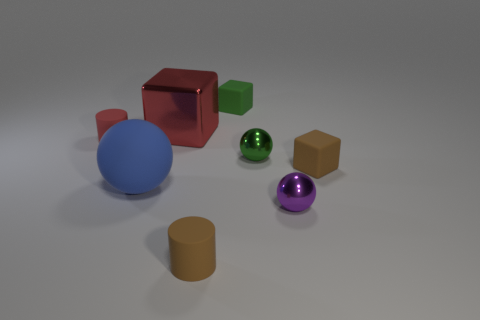What shape is the small red thing?
Provide a short and direct response. Cylinder. There is a brown matte object behind the tiny cylinder that is in front of the tiny red thing; what shape is it?
Your answer should be compact. Cube. Is the cylinder that is to the left of the small brown matte cylinder made of the same material as the green cube?
Your answer should be very brief. Yes. How many red things are either cylinders or large metal blocks?
Your answer should be very brief. 2. Is there another matte block of the same color as the large block?
Give a very brief answer. No. Are there any tiny purple spheres that have the same material as the large cube?
Keep it short and to the point. Yes. There is a tiny object that is both to the left of the green rubber cube and to the right of the big blue rubber ball; what shape is it?
Your answer should be very brief. Cylinder. How many tiny objects are purple metallic spheres or cylinders?
Provide a succinct answer. 3. What is the material of the green ball?
Your answer should be compact. Metal. What number of other objects are the same shape as the red rubber object?
Keep it short and to the point. 1. 